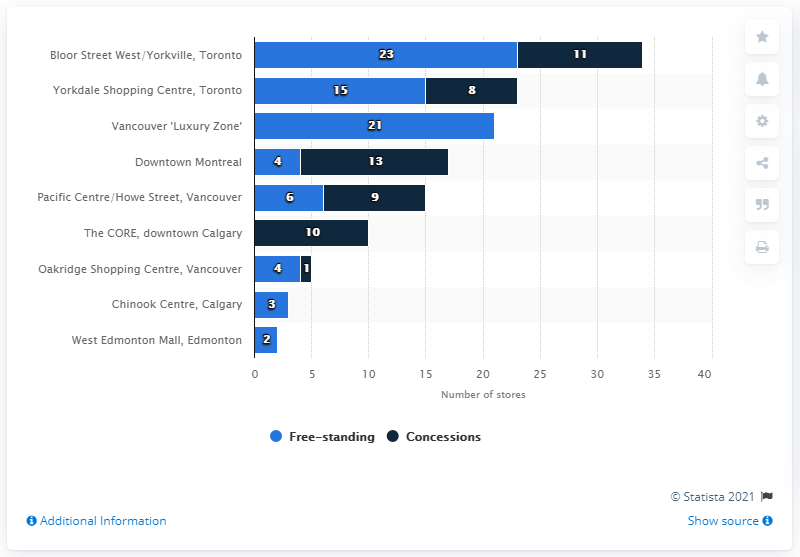Draw attention to some important aspects in this diagram. There were 11 concessions in Bloor Street West/Yorkville in 2015. Bloor Street West and Yorkville had a total of 23 free-standing luxury brands. 